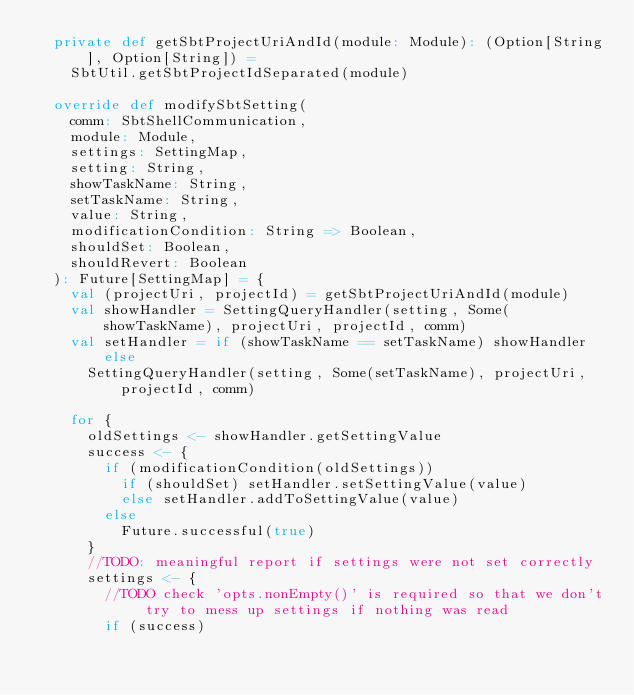Convert code to text. <code><loc_0><loc_0><loc_500><loc_500><_Scala_>  private def getSbtProjectUriAndId(module: Module): (Option[String], Option[String]) =
    SbtUtil.getSbtProjectIdSeparated(module)

  override def modifySbtSetting(
    comm: SbtShellCommunication,
    module: Module,
    settings: SettingMap,
    setting: String,
    showTaskName: String,
    setTaskName: String,
    value: String,
    modificationCondition: String => Boolean,
    shouldSet: Boolean,
    shouldRevert: Boolean
  ): Future[SettingMap] = {
    val (projectUri, projectId) = getSbtProjectUriAndId(module)
    val showHandler = SettingQueryHandler(setting, Some(showTaskName), projectUri, projectId, comm)
    val setHandler = if (showTaskName == setTaskName) showHandler else
      SettingQueryHandler(setting, Some(setTaskName), projectUri, projectId, comm)

    for {
      oldSettings <- showHandler.getSettingValue
      success <- {
        if (modificationCondition(oldSettings))
          if (shouldSet) setHandler.setSettingValue(value)
          else setHandler.addToSettingValue(value)
        else
          Future.successful(true)
      }
      //TODO: meaningful report if settings were not set correctly
      settings <- {
        //TODO check 'opts.nonEmpty()' is required so that we don't try to mess up settings if nothing was read
        if (success)</code> 